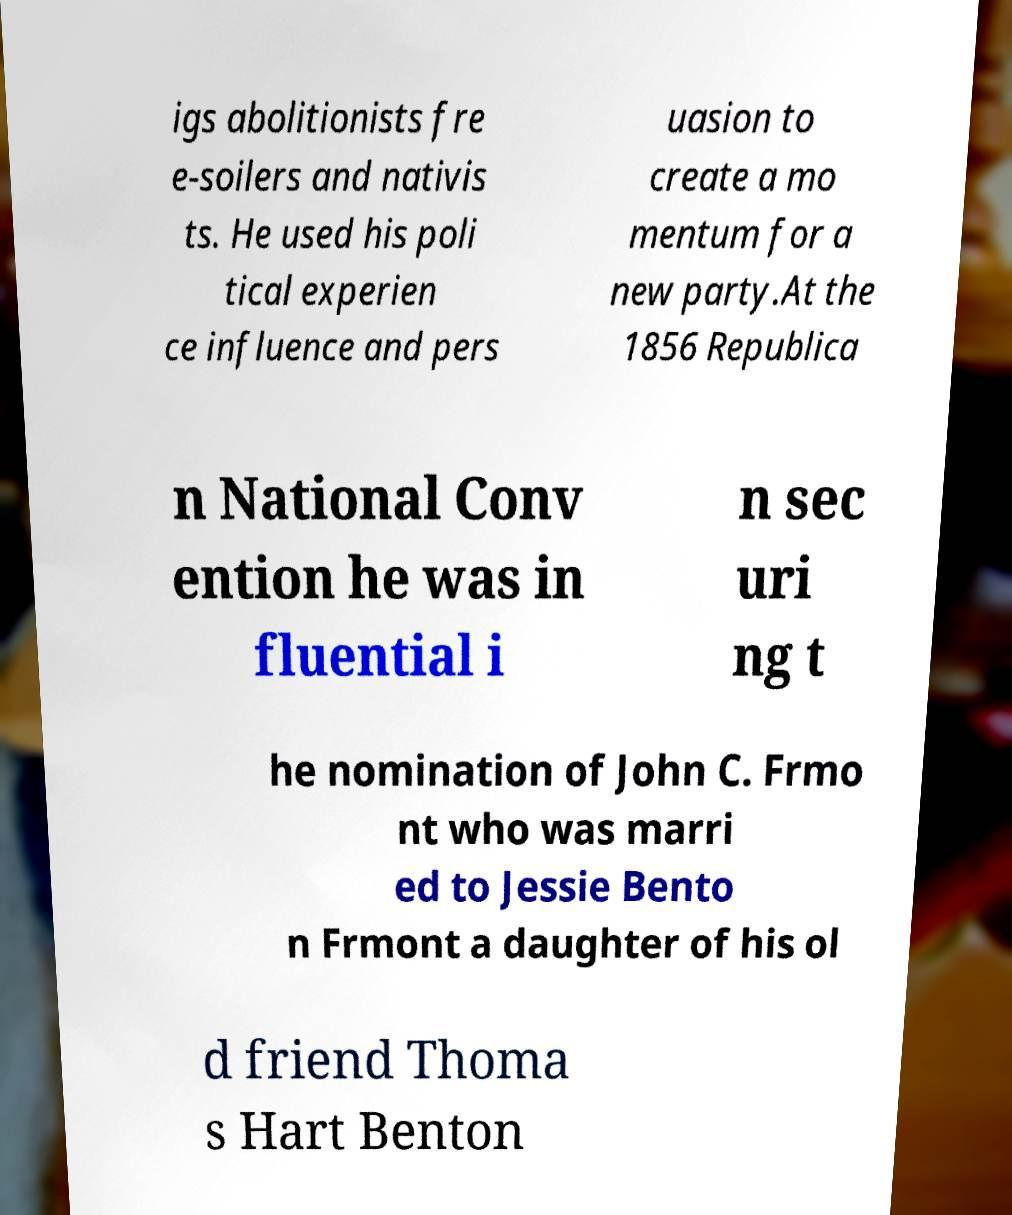What messages or text are displayed in this image? I need them in a readable, typed format. igs abolitionists fre e-soilers and nativis ts. He used his poli tical experien ce influence and pers uasion to create a mo mentum for a new party.At the 1856 Republica n National Conv ention he was in fluential i n sec uri ng t he nomination of John C. Frmo nt who was marri ed to Jessie Bento n Frmont a daughter of his ol d friend Thoma s Hart Benton 